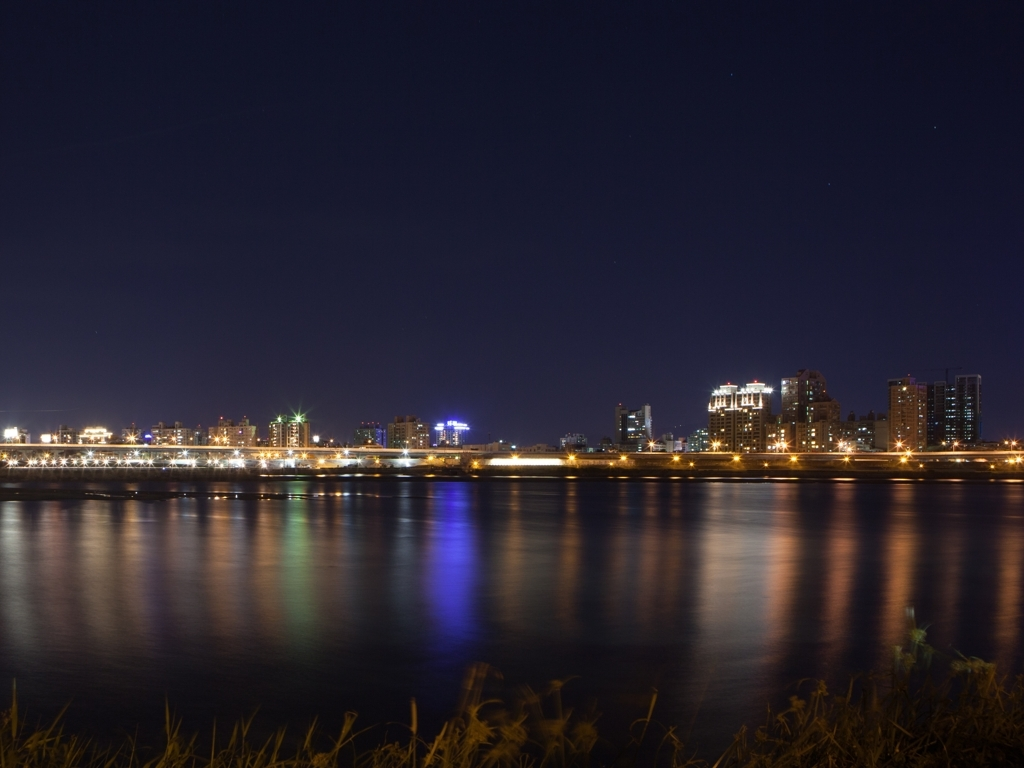Is the quality of this picture acceptable? The quality of the image appears to be quite good with a clear depiction of the city skyline at night. The lights are well-captured with minimal blur, and the reflections on the water give a nice effect of calm and serenity. Its high resolution allows for details to be seen upon zooming in, making it suitable for various uses like print or web content. 